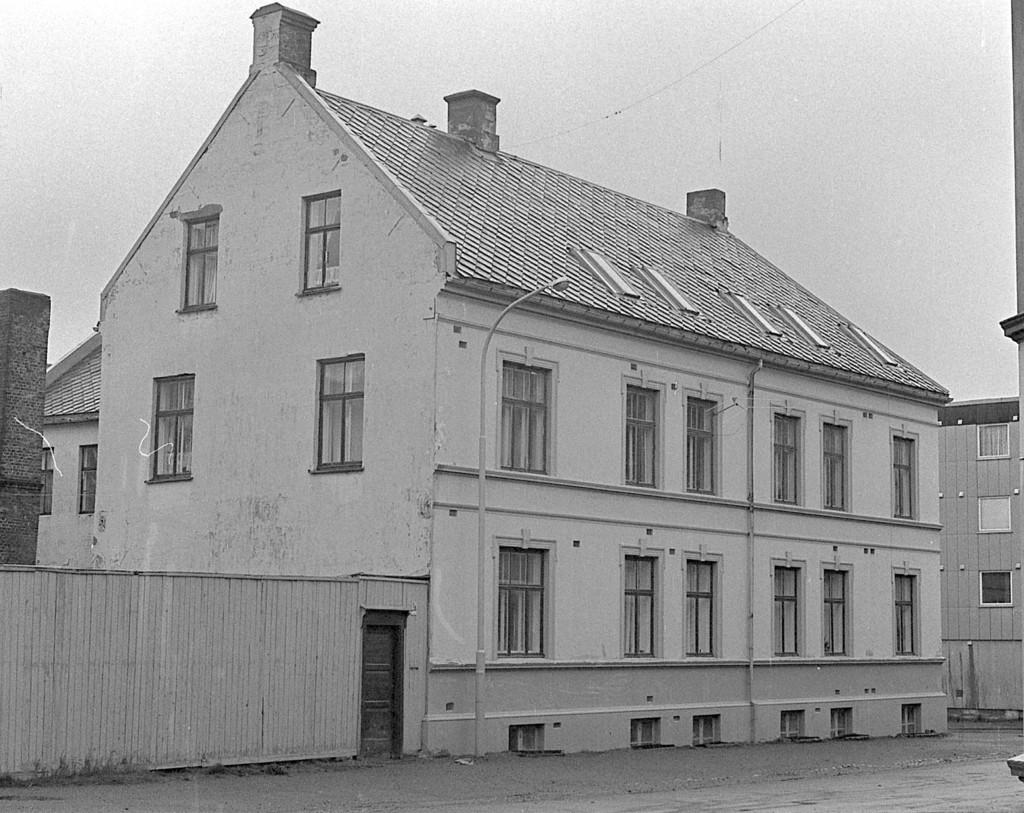What type of structures can be seen in the image? There are buildings in the image. What are the light poles used for in the image? The light poles provide illumination in the image. What is the status of the door on the left side of the image? The door on the left side of the image is closed. What is the purpose of the wall in the image? The wall serves as a barrier or boundary in the image. What is visible at the top of the image? The sky is visible at the top of the image. How many trees are present in the image? There are no trees mentioned or visible in the image. What type of loss is depicted in the image? There is no loss depicted in the image; it features buildings, light poles, a closed door, a wall, and the sky. 